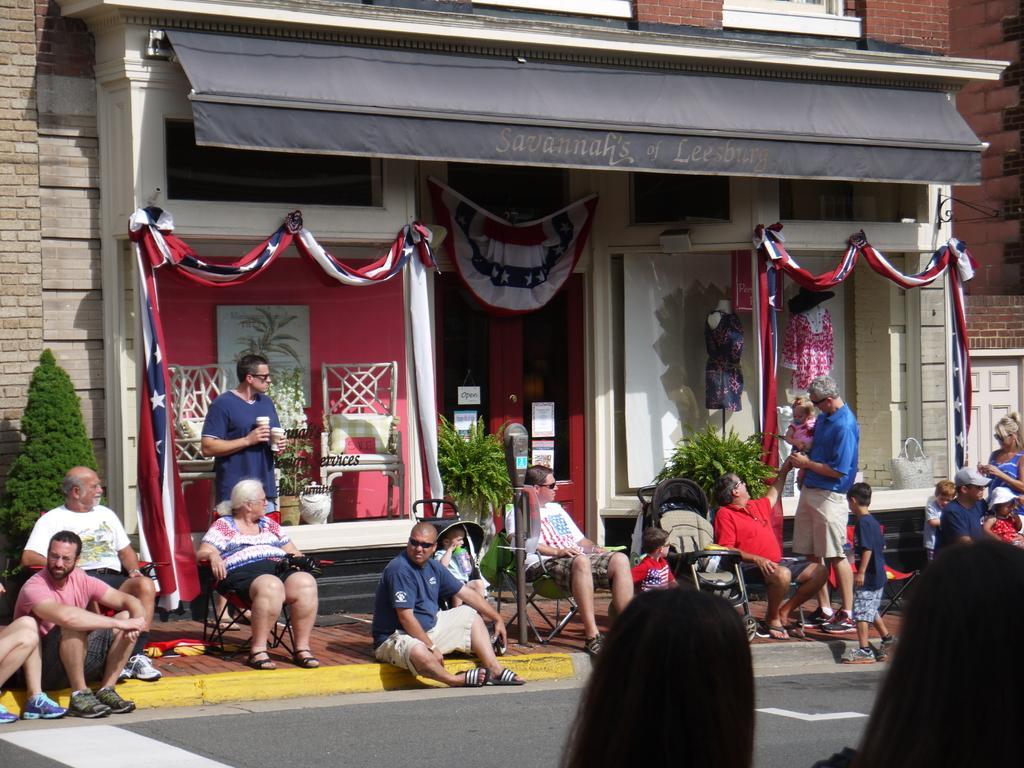Describe this image in one or two sentences. This picture shows a building and we see few people seated on the ground and few are seated on the chair and we see a man standing and holding cups in his hands we see a man standing and holding a baby in his hand and we see few of them wore sunglasses on their faces and we see plants and a couple of mannequins and a tree on the side. 